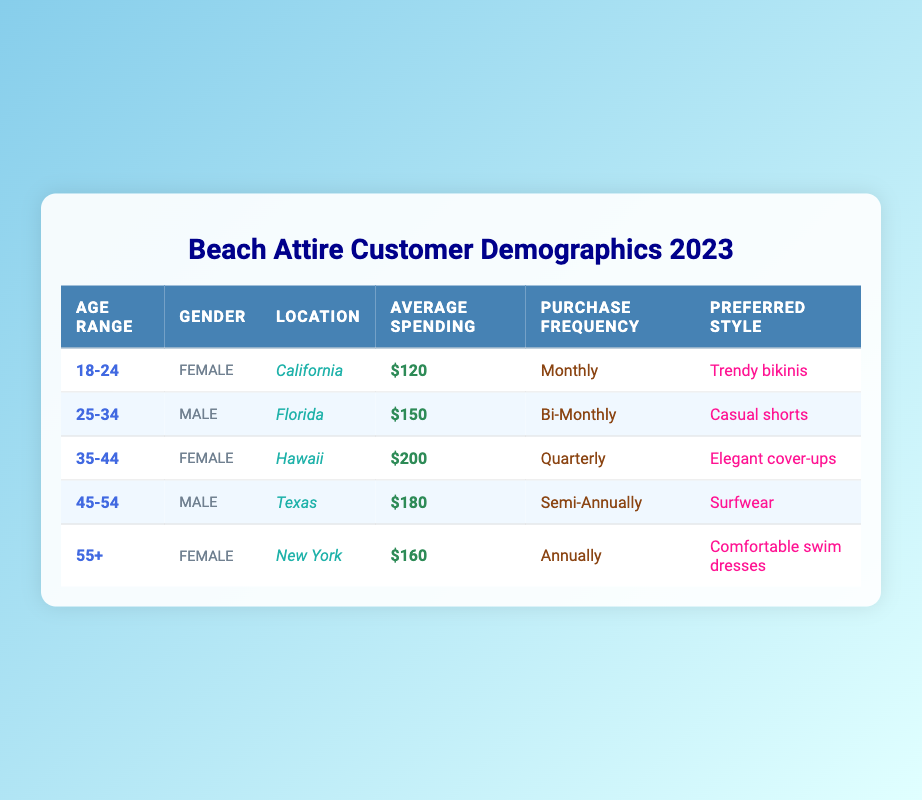What is the preferred style for customers aged 25-34? The entry for customers aged 25-34 shows that their preferred style is "Casual shorts." This is directly stated in the table under the "Preferred Style" column for that age range.
Answer: Casual shorts Which age group has the highest average spending? By examining the "Average Spending" values for each age range, the group aged 35-44 has the highest average spending at $200, which is greater than the spending of all other age groups listed.
Answer: 35-44 What is the purchase frequency for customers aged 55 and above? The entry for customers aged 55 and above indicates that their purchase frequency is listed as "Annually" in the table. This information is directly provided under the "Purchase Frequency" column.
Answer: Annually What is the average spending of all male customers in the data? To find the average spending of male customers, we look at the entries for both the 25-34 (average spending $150) and 45-54 (average spending $180) age ranges. Summing these values gives $150 + $180 = $330. There are 2 male customers, so the average is $330 / 2 = $165.
Answer: 165 Are there more female customers than male customers in the data? The table lists a total of 3 female customers (18-24, 35-44, 55+) and 2 male customers (25-34, 45-54). Since 3 is greater than 2, the answer is yes.
Answer: Yes What percentage of customers purchase on a monthly basis? There is 1 customer who purchases monthly (age 18-24) out of a total of 5 customers in the table, which gives us the percentage (1/5) * 100 = 20%.
Answer: 20 Which locations have customers with average spending below $160? By inspecting the "Average Spending" column, we see that the customers from California ($120) and Florida ($150) have average spending below $160. Therefore, the locations are California and Florida.
Answer: California, Florida How many customers prefer "Trendy bikinis"? Looking at the table, only the customer aged 18-24 has "Trendy bikinis" as their preferred style. There are no other entries for this style, making the total count 1.
Answer: 1 Which age group has the least frequent purchases? The group aged 55+ has the purchase frequency listed as "Annually," which is less frequent than all other age groups listed (monthly, bi-monthly, quarterly, semi-annually). Thus, this age group has the least frequent purchases.
Answer: 55+ 